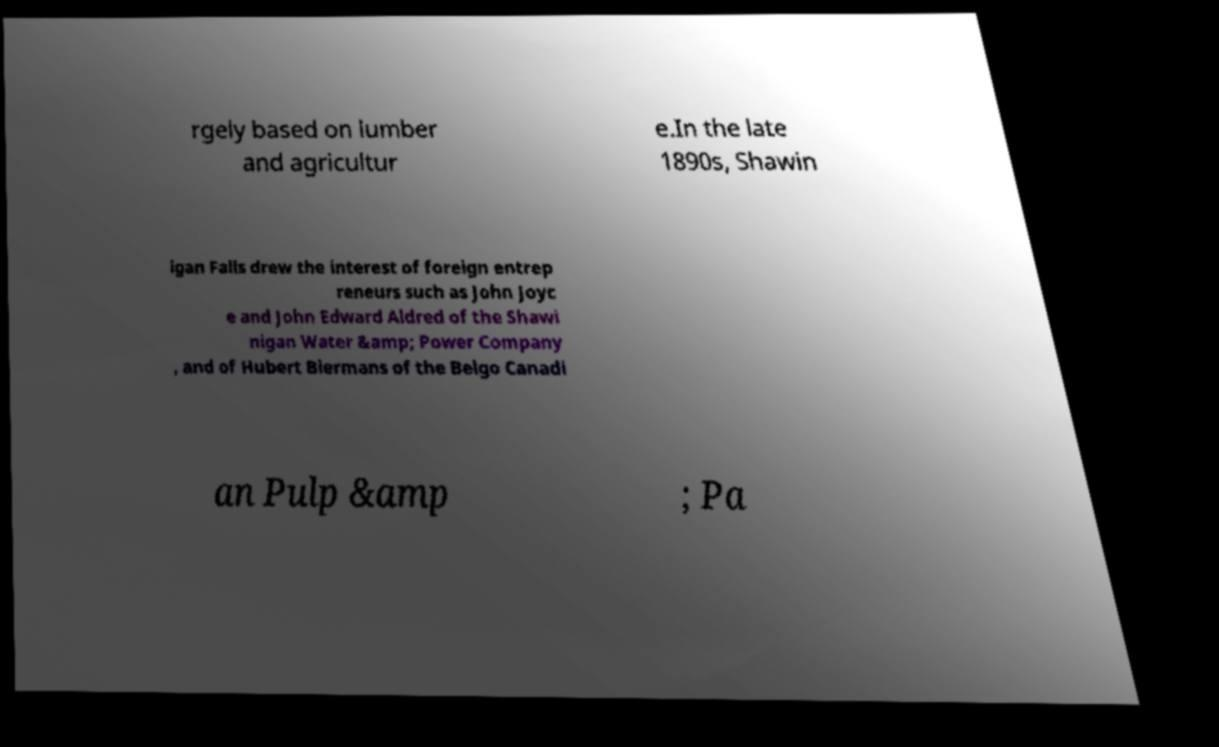For documentation purposes, I need the text within this image transcribed. Could you provide that? rgely based on lumber and agricultur e.In the late 1890s, Shawin igan Falls drew the interest of foreign entrep reneurs such as John Joyc e and John Edward Aldred of the Shawi nigan Water &amp; Power Company , and of Hubert Biermans of the Belgo Canadi an Pulp &amp ; Pa 